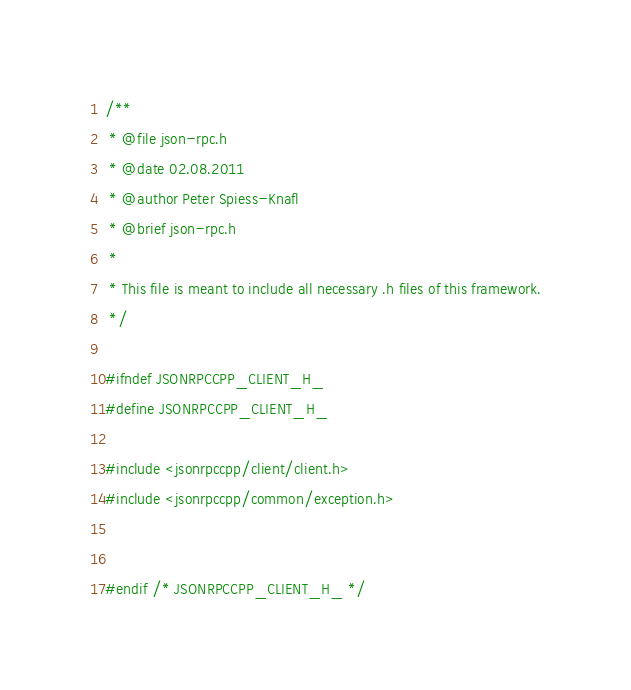<code> <loc_0><loc_0><loc_500><loc_500><_C_>/**
 * @file json-rpc.h
 * @date 02.08.2011
 * @author Peter Spiess-Knafl
 * @brief json-rpc.h
 *
 * This file is meant to include all necessary .h files of this framework.
 */

#ifndef JSONRPCCPP_CLIENT_H_
#define JSONRPCCPP_CLIENT_H_

#include <jsonrpccpp/client/client.h>
#include <jsonrpccpp/common/exception.h>


#endif /* JSONRPCCPP_CLIENT_H_ */
</code> 